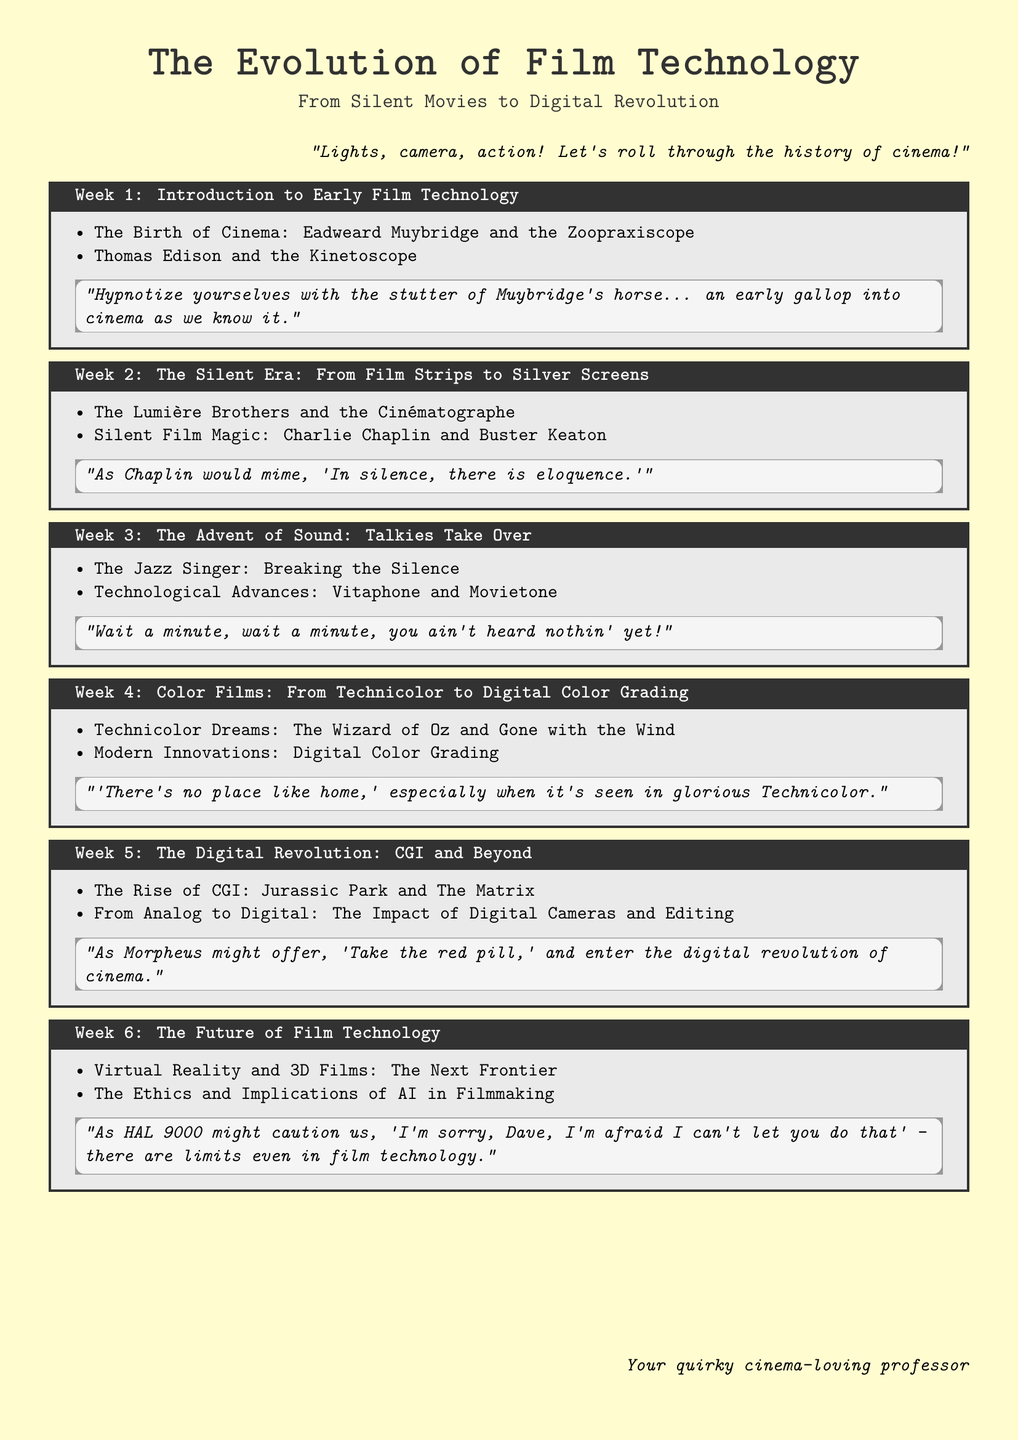What is the title of the syllabus? The title of the syllabus is prominently displayed at the beginning of the document.
Answer: The Evolution of Film Technology Who is associated with the Kinetoscope? The Kinetoscope is credited to a significant figure in early film technology mentioned in Week 1.
Answer: Thomas Edison What is the key film highlighted in the discussion of the advent of sound? The document references a specific film that is pivotal in the transition to sound in Week 3.
Answer: The Jazz Singer What technology transformed color films as mentioned in Week 4? The document specifies a significant color technology in the history of filmmaking.
Answer: Technicolor Which movie is cited for its CGI innovation in Week 5? One notable film that exemplifies CGI advances is mentioned in the section about the digital revolution.
Answer: Jurassic Park How many weeks are dedicated to the topics in this syllabus? The document outlines a structured timetable, which provides the number of weeks covered.
Answer: Six 